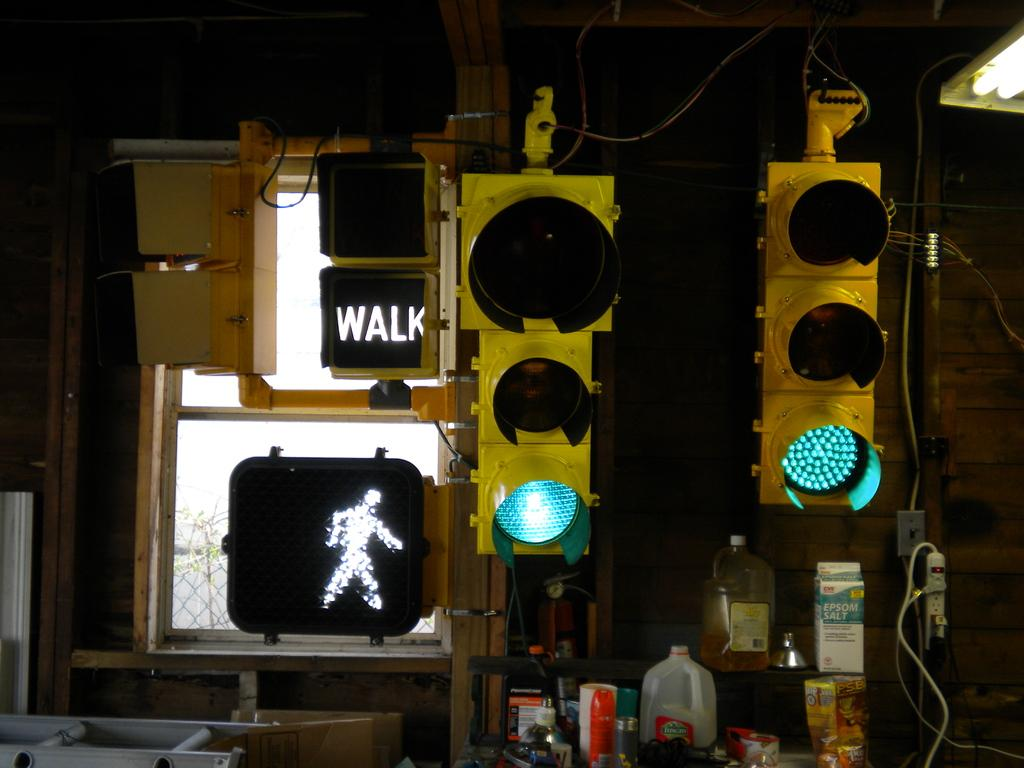<image>
Give a short and clear explanation of the subsequent image. A traffic light that is green and a sign that says walk. 